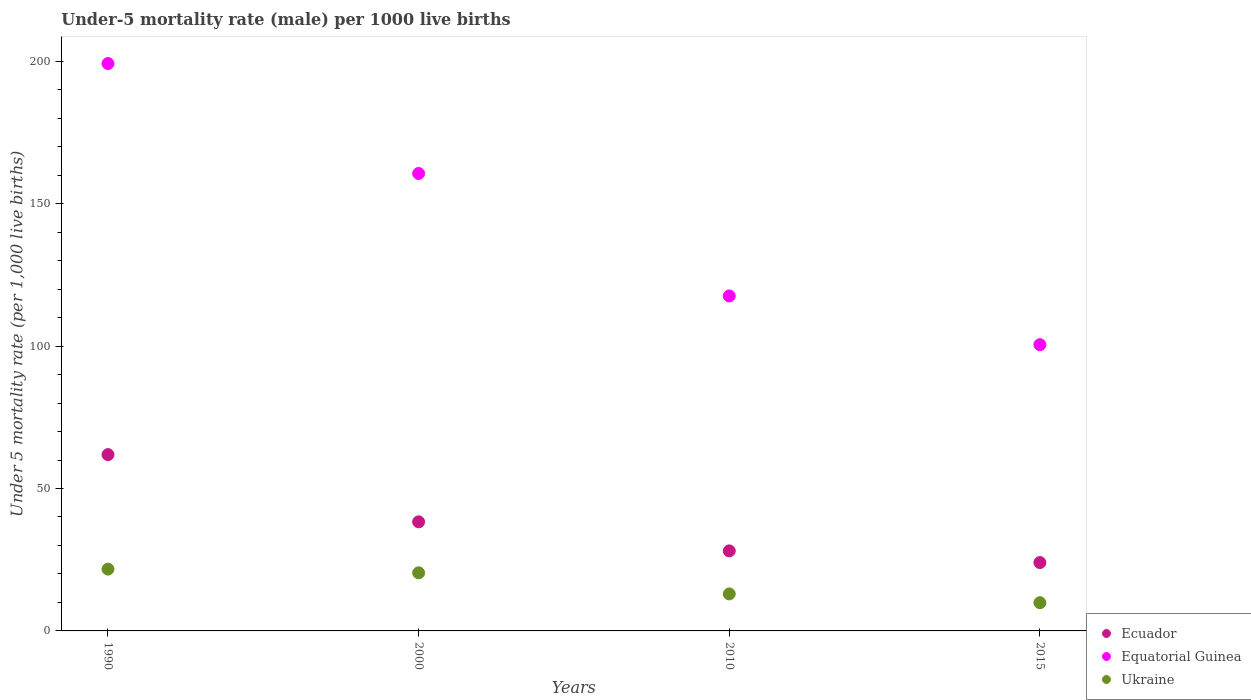How many different coloured dotlines are there?
Your answer should be very brief. 3. What is the under-five mortality rate in Ecuador in 2000?
Keep it short and to the point. 38.3. Across all years, what is the maximum under-five mortality rate in Ukraine?
Offer a very short reply. 21.7. In which year was the under-five mortality rate in Ecuador maximum?
Give a very brief answer. 1990. In which year was the under-five mortality rate in Ecuador minimum?
Make the answer very short. 2015. What is the total under-five mortality rate in Ukraine in the graph?
Offer a terse response. 65. What is the difference between the under-five mortality rate in Equatorial Guinea in 1990 and that in 2010?
Offer a very short reply. 81.6. What is the difference between the under-five mortality rate in Equatorial Guinea in 2015 and the under-five mortality rate in Ecuador in 2000?
Keep it short and to the point. 62.2. What is the average under-five mortality rate in Ecuador per year?
Your answer should be compact. 38.07. In the year 2000, what is the difference between the under-five mortality rate in Ecuador and under-five mortality rate in Equatorial Guinea?
Your answer should be compact. -122.3. What is the ratio of the under-five mortality rate in Ecuador in 1990 to that in 2000?
Make the answer very short. 1.62. Is the difference between the under-five mortality rate in Ecuador in 2000 and 2015 greater than the difference between the under-five mortality rate in Equatorial Guinea in 2000 and 2015?
Ensure brevity in your answer.  No. What is the difference between the highest and the second highest under-five mortality rate in Ukraine?
Your answer should be compact. 1.3. What is the difference between the highest and the lowest under-five mortality rate in Ukraine?
Provide a succinct answer. 11.8. Is the sum of the under-five mortality rate in Equatorial Guinea in 2000 and 2010 greater than the maximum under-five mortality rate in Ukraine across all years?
Offer a very short reply. Yes. Is it the case that in every year, the sum of the under-five mortality rate in Equatorial Guinea and under-five mortality rate in Ecuador  is greater than the under-five mortality rate in Ukraine?
Provide a short and direct response. Yes. Is the under-five mortality rate in Ukraine strictly greater than the under-five mortality rate in Equatorial Guinea over the years?
Your response must be concise. No. Is the under-five mortality rate in Equatorial Guinea strictly less than the under-five mortality rate in Ecuador over the years?
Offer a terse response. No. What is the difference between two consecutive major ticks on the Y-axis?
Provide a short and direct response. 50. Does the graph contain grids?
Offer a terse response. No. What is the title of the graph?
Give a very brief answer. Under-5 mortality rate (male) per 1000 live births. Does "Lebanon" appear as one of the legend labels in the graph?
Make the answer very short. No. What is the label or title of the Y-axis?
Give a very brief answer. Under 5 mortality rate (per 1,0 live births). What is the Under 5 mortality rate (per 1,000 live births) of Ecuador in 1990?
Your answer should be compact. 61.9. What is the Under 5 mortality rate (per 1,000 live births) of Equatorial Guinea in 1990?
Make the answer very short. 199.2. What is the Under 5 mortality rate (per 1,000 live births) of Ukraine in 1990?
Give a very brief answer. 21.7. What is the Under 5 mortality rate (per 1,000 live births) of Ecuador in 2000?
Your answer should be very brief. 38.3. What is the Under 5 mortality rate (per 1,000 live births) in Equatorial Guinea in 2000?
Offer a very short reply. 160.6. What is the Under 5 mortality rate (per 1,000 live births) in Ukraine in 2000?
Ensure brevity in your answer.  20.4. What is the Under 5 mortality rate (per 1,000 live births) of Ecuador in 2010?
Provide a succinct answer. 28.1. What is the Under 5 mortality rate (per 1,000 live births) of Equatorial Guinea in 2010?
Give a very brief answer. 117.6. What is the Under 5 mortality rate (per 1,000 live births) in Ukraine in 2010?
Offer a very short reply. 13. What is the Under 5 mortality rate (per 1,000 live births) of Ecuador in 2015?
Provide a succinct answer. 24. What is the Under 5 mortality rate (per 1,000 live births) of Equatorial Guinea in 2015?
Your response must be concise. 100.5. Across all years, what is the maximum Under 5 mortality rate (per 1,000 live births) in Ecuador?
Your answer should be very brief. 61.9. Across all years, what is the maximum Under 5 mortality rate (per 1,000 live births) in Equatorial Guinea?
Your answer should be compact. 199.2. Across all years, what is the maximum Under 5 mortality rate (per 1,000 live births) in Ukraine?
Your answer should be compact. 21.7. Across all years, what is the minimum Under 5 mortality rate (per 1,000 live births) in Ecuador?
Offer a terse response. 24. Across all years, what is the minimum Under 5 mortality rate (per 1,000 live births) of Equatorial Guinea?
Provide a short and direct response. 100.5. Across all years, what is the minimum Under 5 mortality rate (per 1,000 live births) of Ukraine?
Ensure brevity in your answer.  9.9. What is the total Under 5 mortality rate (per 1,000 live births) of Ecuador in the graph?
Provide a short and direct response. 152.3. What is the total Under 5 mortality rate (per 1,000 live births) in Equatorial Guinea in the graph?
Keep it short and to the point. 577.9. What is the difference between the Under 5 mortality rate (per 1,000 live births) of Ecuador in 1990 and that in 2000?
Offer a terse response. 23.6. What is the difference between the Under 5 mortality rate (per 1,000 live births) in Equatorial Guinea in 1990 and that in 2000?
Keep it short and to the point. 38.6. What is the difference between the Under 5 mortality rate (per 1,000 live births) of Ukraine in 1990 and that in 2000?
Ensure brevity in your answer.  1.3. What is the difference between the Under 5 mortality rate (per 1,000 live births) of Ecuador in 1990 and that in 2010?
Make the answer very short. 33.8. What is the difference between the Under 5 mortality rate (per 1,000 live births) in Equatorial Guinea in 1990 and that in 2010?
Keep it short and to the point. 81.6. What is the difference between the Under 5 mortality rate (per 1,000 live births) of Ecuador in 1990 and that in 2015?
Offer a very short reply. 37.9. What is the difference between the Under 5 mortality rate (per 1,000 live births) of Equatorial Guinea in 1990 and that in 2015?
Your response must be concise. 98.7. What is the difference between the Under 5 mortality rate (per 1,000 live births) of Ukraine in 1990 and that in 2015?
Keep it short and to the point. 11.8. What is the difference between the Under 5 mortality rate (per 1,000 live births) in Ecuador in 2000 and that in 2010?
Offer a terse response. 10.2. What is the difference between the Under 5 mortality rate (per 1,000 live births) of Equatorial Guinea in 2000 and that in 2015?
Provide a succinct answer. 60.1. What is the difference between the Under 5 mortality rate (per 1,000 live births) of Ecuador in 2010 and that in 2015?
Your answer should be compact. 4.1. What is the difference between the Under 5 mortality rate (per 1,000 live births) in Equatorial Guinea in 2010 and that in 2015?
Your answer should be very brief. 17.1. What is the difference between the Under 5 mortality rate (per 1,000 live births) of Ukraine in 2010 and that in 2015?
Offer a terse response. 3.1. What is the difference between the Under 5 mortality rate (per 1,000 live births) of Ecuador in 1990 and the Under 5 mortality rate (per 1,000 live births) of Equatorial Guinea in 2000?
Give a very brief answer. -98.7. What is the difference between the Under 5 mortality rate (per 1,000 live births) of Ecuador in 1990 and the Under 5 mortality rate (per 1,000 live births) of Ukraine in 2000?
Provide a short and direct response. 41.5. What is the difference between the Under 5 mortality rate (per 1,000 live births) of Equatorial Guinea in 1990 and the Under 5 mortality rate (per 1,000 live births) of Ukraine in 2000?
Give a very brief answer. 178.8. What is the difference between the Under 5 mortality rate (per 1,000 live births) in Ecuador in 1990 and the Under 5 mortality rate (per 1,000 live births) in Equatorial Guinea in 2010?
Keep it short and to the point. -55.7. What is the difference between the Under 5 mortality rate (per 1,000 live births) of Ecuador in 1990 and the Under 5 mortality rate (per 1,000 live births) of Ukraine in 2010?
Offer a very short reply. 48.9. What is the difference between the Under 5 mortality rate (per 1,000 live births) of Equatorial Guinea in 1990 and the Under 5 mortality rate (per 1,000 live births) of Ukraine in 2010?
Your answer should be compact. 186.2. What is the difference between the Under 5 mortality rate (per 1,000 live births) in Ecuador in 1990 and the Under 5 mortality rate (per 1,000 live births) in Equatorial Guinea in 2015?
Your response must be concise. -38.6. What is the difference between the Under 5 mortality rate (per 1,000 live births) in Equatorial Guinea in 1990 and the Under 5 mortality rate (per 1,000 live births) in Ukraine in 2015?
Provide a short and direct response. 189.3. What is the difference between the Under 5 mortality rate (per 1,000 live births) in Ecuador in 2000 and the Under 5 mortality rate (per 1,000 live births) in Equatorial Guinea in 2010?
Provide a succinct answer. -79.3. What is the difference between the Under 5 mortality rate (per 1,000 live births) of Ecuador in 2000 and the Under 5 mortality rate (per 1,000 live births) of Ukraine in 2010?
Provide a short and direct response. 25.3. What is the difference between the Under 5 mortality rate (per 1,000 live births) of Equatorial Guinea in 2000 and the Under 5 mortality rate (per 1,000 live births) of Ukraine in 2010?
Provide a succinct answer. 147.6. What is the difference between the Under 5 mortality rate (per 1,000 live births) of Ecuador in 2000 and the Under 5 mortality rate (per 1,000 live births) of Equatorial Guinea in 2015?
Your answer should be compact. -62.2. What is the difference between the Under 5 mortality rate (per 1,000 live births) of Ecuador in 2000 and the Under 5 mortality rate (per 1,000 live births) of Ukraine in 2015?
Your response must be concise. 28.4. What is the difference between the Under 5 mortality rate (per 1,000 live births) in Equatorial Guinea in 2000 and the Under 5 mortality rate (per 1,000 live births) in Ukraine in 2015?
Your answer should be very brief. 150.7. What is the difference between the Under 5 mortality rate (per 1,000 live births) of Ecuador in 2010 and the Under 5 mortality rate (per 1,000 live births) of Equatorial Guinea in 2015?
Keep it short and to the point. -72.4. What is the difference between the Under 5 mortality rate (per 1,000 live births) in Equatorial Guinea in 2010 and the Under 5 mortality rate (per 1,000 live births) in Ukraine in 2015?
Your answer should be compact. 107.7. What is the average Under 5 mortality rate (per 1,000 live births) of Ecuador per year?
Provide a short and direct response. 38.08. What is the average Under 5 mortality rate (per 1,000 live births) of Equatorial Guinea per year?
Ensure brevity in your answer.  144.47. What is the average Under 5 mortality rate (per 1,000 live births) in Ukraine per year?
Your answer should be compact. 16.25. In the year 1990, what is the difference between the Under 5 mortality rate (per 1,000 live births) of Ecuador and Under 5 mortality rate (per 1,000 live births) of Equatorial Guinea?
Provide a succinct answer. -137.3. In the year 1990, what is the difference between the Under 5 mortality rate (per 1,000 live births) in Ecuador and Under 5 mortality rate (per 1,000 live births) in Ukraine?
Offer a terse response. 40.2. In the year 1990, what is the difference between the Under 5 mortality rate (per 1,000 live births) in Equatorial Guinea and Under 5 mortality rate (per 1,000 live births) in Ukraine?
Ensure brevity in your answer.  177.5. In the year 2000, what is the difference between the Under 5 mortality rate (per 1,000 live births) of Ecuador and Under 5 mortality rate (per 1,000 live births) of Equatorial Guinea?
Provide a short and direct response. -122.3. In the year 2000, what is the difference between the Under 5 mortality rate (per 1,000 live births) in Equatorial Guinea and Under 5 mortality rate (per 1,000 live births) in Ukraine?
Your response must be concise. 140.2. In the year 2010, what is the difference between the Under 5 mortality rate (per 1,000 live births) of Ecuador and Under 5 mortality rate (per 1,000 live births) of Equatorial Guinea?
Give a very brief answer. -89.5. In the year 2010, what is the difference between the Under 5 mortality rate (per 1,000 live births) of Ecuador and Under 5 mortality rate (per 1,000 live births) of Ukraine?
Offer a terse response. 15.1. In the year 2010, what is the difference between the Under 5 mortality rate (per 1,000 live births) in Equatorial Guinea and Under 5 mortality rate (per 1,000 live births) in Ukraine?
Provide a short and direct response. 104.6. In the year 2015, what is the difference between the Under 5 mortality rate (per 1,000 live births) of Ecuador and Under 5 mortality rate (per 1,000 live births) of Equatorial Guinea?
Keep it short and to the point. -76.5. In the year 2015, what is the difference between the Under 5 mortality rate (per 1,000 live births) of Ecuador and Under 5 mortality rate (per 1,000 live births) of Ukraine?
Give a very brief answer. 14.1. In the year 2015, what is the difference between the Under 5 mortality rate (per 1,000 live births) of Equatorial Guinea and Under 5 mortality rate (per 1,000 live births) of Ukraine?
Your answer should be very brief. 90.6. What is the ratio of the Under 5 mortality rate (per 1,000 live births) of Ecuador in 1990 to that in 2000?
Offer a very short reply. 1.62. What is the ratio of the Under 5 mortality rate (per 1,000 live births) of Equatorial Guinea in 1990 to that in 2000?
Provide a short and direct response. 1.24. What is the ratio of the Under 5 mortality rate (per 1,000 live births) in Ukraine in 1990 to that in 2000?
Provide a short and direct response. 1.06. What is the ratio of the Under 5 mortality rate (per 1,000 live births) in Ecuador in 1990 to that in 2010?
Offer a very short reply. 2.2. What is the ratio of the Under 5 mortality rate (per 1,000 live births) of Equatorial Guinea in 1990 to that in 2010?
Your response must be concise. 1.69. What is the ratio of the Under 5 mortality rate (per 1,000 live births) of Ukraine in 1990 to that in 2010?
Your response must be concise. 1.67. What is the ratio of the Under 5 mortality rate (per 1,000 live births) in Ecuador in 1990 to that in 2015?
Ensure brevity in your answer.  2.58. What is the ratio of the Under 5 mortality rate (per 1,000 live births) of Equatorial Guinea in 1990 to that in 2015?
Your answer should be compact. 1.98. What is the ratio of the Under 5 mortality rate (per 1,000 live births) in Ukraine in 1990 to that in 2015?
Give a very brief answer. 2.19. What is the ratio of the Under 5 mortality rate (per 1,000 live births) in Ecuador in 2000 to that in 2010?
Give a very brief answer. 1.36. What is the ratio of the Under 5 mortality rate (per 1,000 live births) of Equatorial Guinea in 2000 to that in 2010?
Your answer should be very brief. 1.37. What is the ratio of the Under 5 mortality rate (per 1,000 live births) in Ukraine in 2000 to that in 2010?
Keep it short and to the point. 1.57. What is the ratio of the Under 5 mortality rate (per 1,000 live births) of Ecuador in 2000 to that in 2015?
Your answer should be compact. 1.6. What is the ratio of the Under 5 mortality rate (per 1,000 live births) of Equatorial Guinea in 2000 to that in 2015?
Your answer should be very brief. 1.6. What is the ratio of the Under 5 mortality rate (per 1,000 live births) in Ukraine in 2000 to that in 2015?
Your answer should be compact. 2.06. What is the ratio of the Under 5 mortality rate (per 1,000 live births) of Ecuador in 2010 to that in 2015?
Your response must be concise. 1.17. What is the ratio of the Under 5 mortality rate (per 1,000 live births) of Equatorial Guinea in 2010 to that in 2015?
Give a very brief answer. 1.17. What is the ratio of the Under 5 mortality rate (per 1,000 live births) of Ukraine in 2010 to that in 2015?
Make the answer very short. 1.31. What is the difference between the highest and the second highest Under 5 mortality rate (per 1,000 live births) of Ecuador?
Offer a very short reply. 23.6. What is the difference between the highest and the second highest Under 5 mortality rate (per 1,000 live births) of Equatorial Guinea?
Provide a succinct answer. 38.6. What is the difference between the highest and the lowest Under 5 mortality rate (per 1,000 live births) in Ecuador?
Provide a short and direct response. 37.9. What is the difference between the highest and the lowest Under 5 mortality rate (per 1,000 live births) in Equatorial Guinea?
Make the answer very short. 98.7. What is the difference between the highest and the lowest Under 5 mortality rate (per 1,000 live births) of Ukraine?
Give a very brief answer. 11.8. 